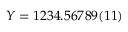<formula> <loc_0><loc_0><loc_500><loc_500>Y = 1 2 3 4 . 5 6 7 8 9 ( 1 1 )</formula> 